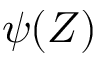<formula> <loc_0><loc_0><loc_500><loc_500>\psi ( Z )</formula> 